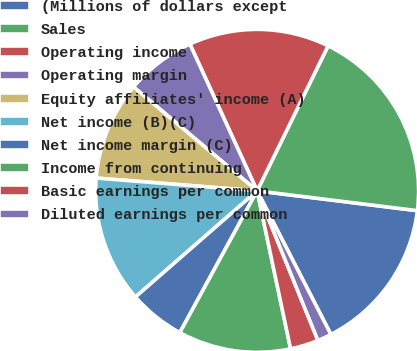Convert chart to OTSL. <chart><loc_0><loc_0><loc_500><loc_500><pie_chart><fcel>(Millions of dollars except<fcel>Sales<fcel>Operating income<fcel>Operating margin<fcel>Equity affiliates' income (A)<fcel>Net income (B)(C)<fcel>Net income margin (C)<fcel>Income from continuing<fcel>Basic earnings per common<fcel>Diluted earnings per common<nl><fcel>15.49%<fcel>19.72%<fcel>14.08%<fcel>7.04%<fcel>9.86%<fcel>12.68%<fcel>5.64%<fcel>11.27%<fcel>2.82%<fcel>1.41%<nl></chart> 